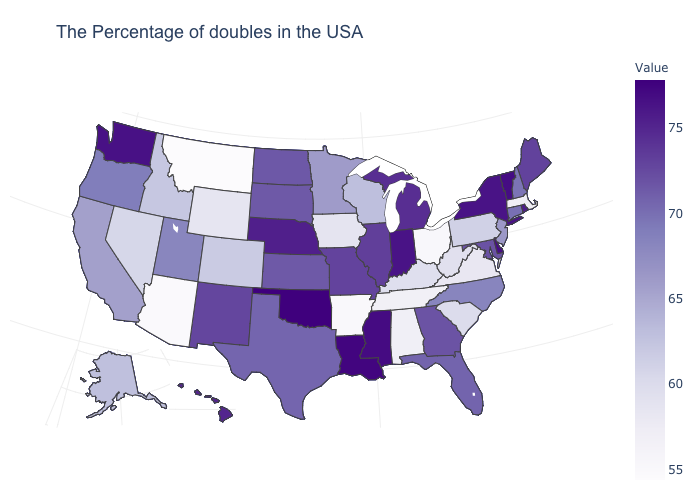Which states hav the highest value in the South?
Keep it brief. Oklahoma. Is the legend a continuous bar?
Short answer required. Yes. Which states have the highest value in the USA?
Short answer required. Oklahoma. Does Tennessee have the highest value in the USA?
Be succinct. No. Among the states that border Missouri , which have the lowest value?
Quick response, please. Arkansas. Among the states that border Arkansas , which have the highest value?
Answer briefly. Oklahoma. 